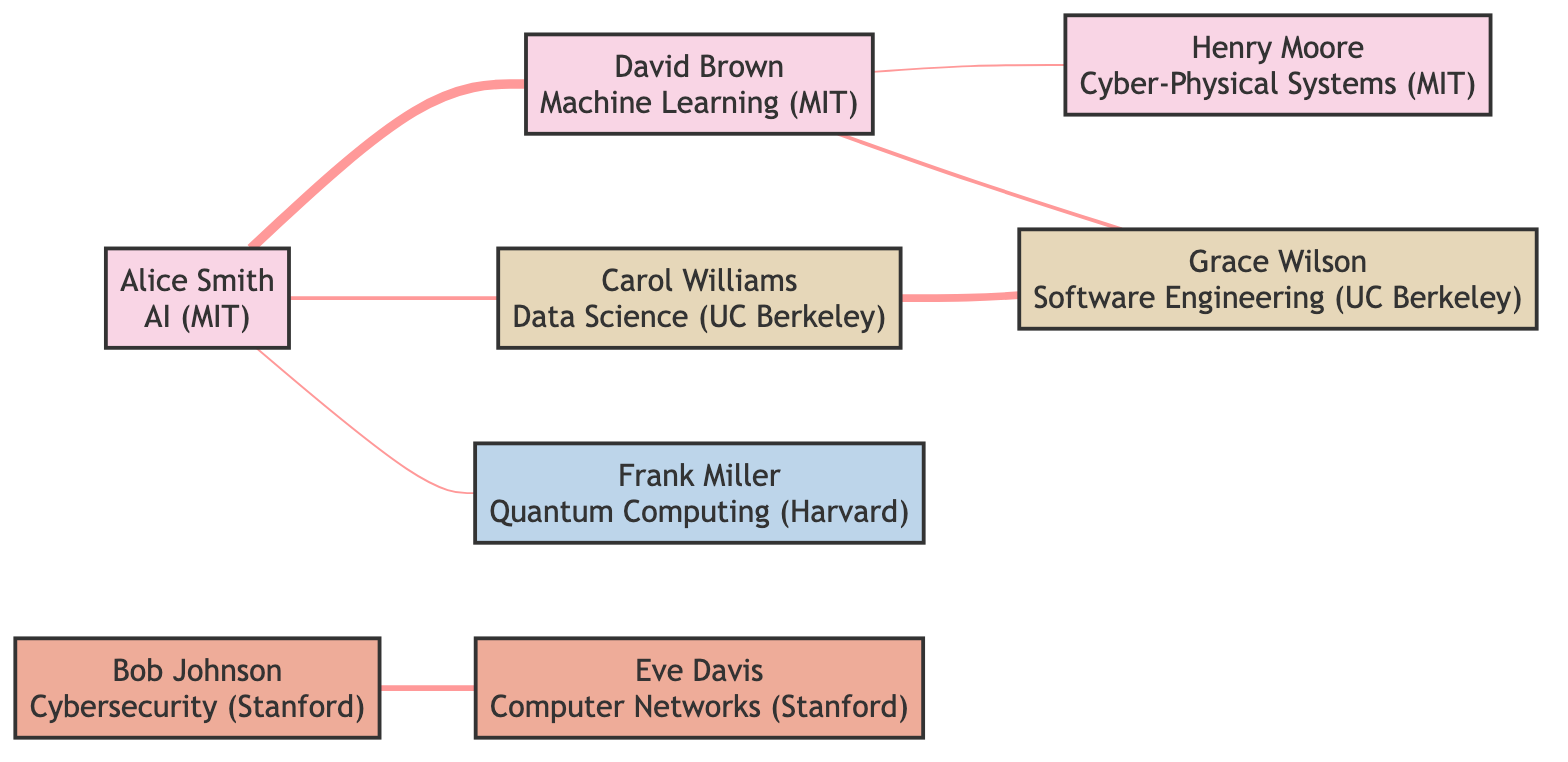What is the total number of nodes in the graph? The graph consists of 8 distinct nodes that represent the computer science faculty authors. By counting each individual node in the provided data, I find that there are 8 unique names listed.
Answer: 8 Who has coauthored publications with Alice Smith? Alice Smith has coauthored publications with David Brown (5 publications), Carol Williams (2 publications), and Frank Miller (1 publication). There are three distinct individuals linked to Alice Smith in the diagram.
Answer: David Brown, Carol Williams, Frank Miller What is the highest number of coauthored publications between any two individuals? By analyzing the edges in the diagram, the highest number of coauthored publications is 5, which is found between Alice Smith and David Brown. This is the highest value listed in the data for coauthored publications.
Answer: 5 Which faculty member has the least number of coauthored publications? Reviewing the edges, the least number of coauthored publications is 1, which occurs between Alice Smith and Frank Miller, as well as between David Brown and Henry Moore. Both pairs show the least collaboration in the graph.
Answer: Frank Miller, Henry Moore Which two departments are connected by the most coauthored publications? Analyzing the collaborative edges, the most connections occur between the Artificial Intelligence (Alice Smith) and Machine Learning (David Brown) departments, amounting to 5 publications for a direct link.
Answer: Artificial Intelligence and Machine Learning How many total coauthored publications exist in the graph? The total number of coauthored publications can be calculated by summing the individual counts of publications from each of the edges: 5 + 2 + 3 + 4 + 1 + 1 + 2 = 18. Thus, there are a total of 18 coauthored publications across the author network.
Answer: 18 Which author is affiliated with Harvard? The graph indicates that Frank Miller is the only author affiliated with Harvard. His name and corresponding department can be clearly identified within the nodes.
Answer: Frank Miller How many authors are affiliated with MIT? By examining the nodes, I find that there are 4 authors affiliated with MIT: Alice Smith, David Brown, and Henry Moore. Their names can be identified under the MIT grouping.
Answer: 4 